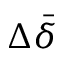<formula> <loc_0><loc_0><loc_500><loc_500>\Delta \bar { \delta }</formula> 